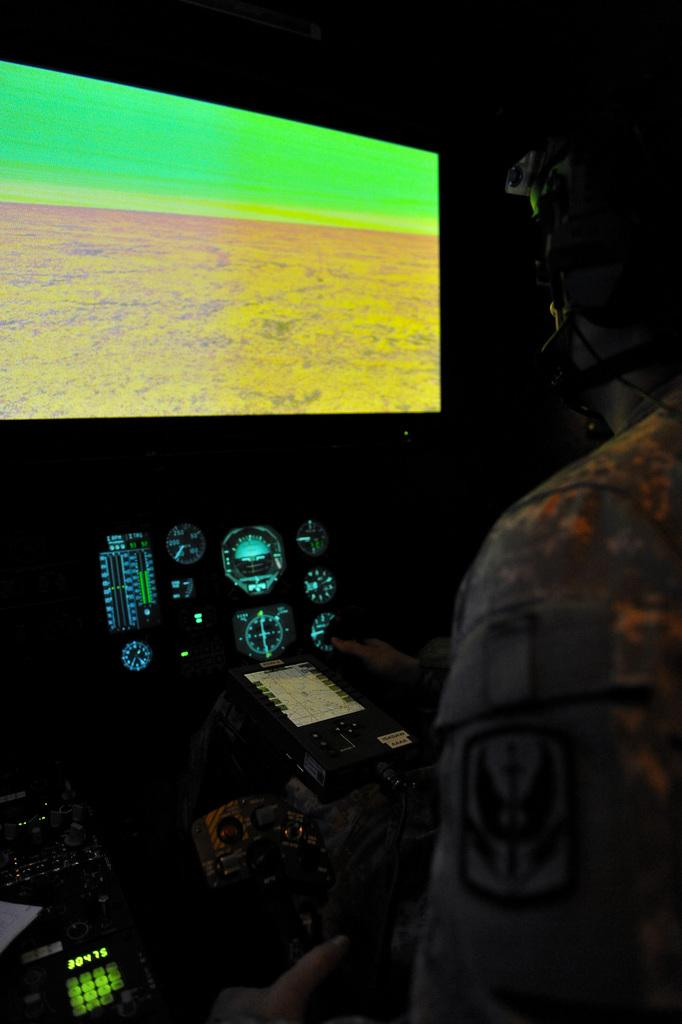What is the main subject of the image? There is a person in the image. What is the person doing in the image? The person is controlling systems. What is in front of the person? There is a screen in front of the person. How would you describe the background of the image? The background of the image appears dark. How many planes can be seen in the room in the image? There is no room or planes present in the image; it features a person controlling systems with a screen in front of them. 